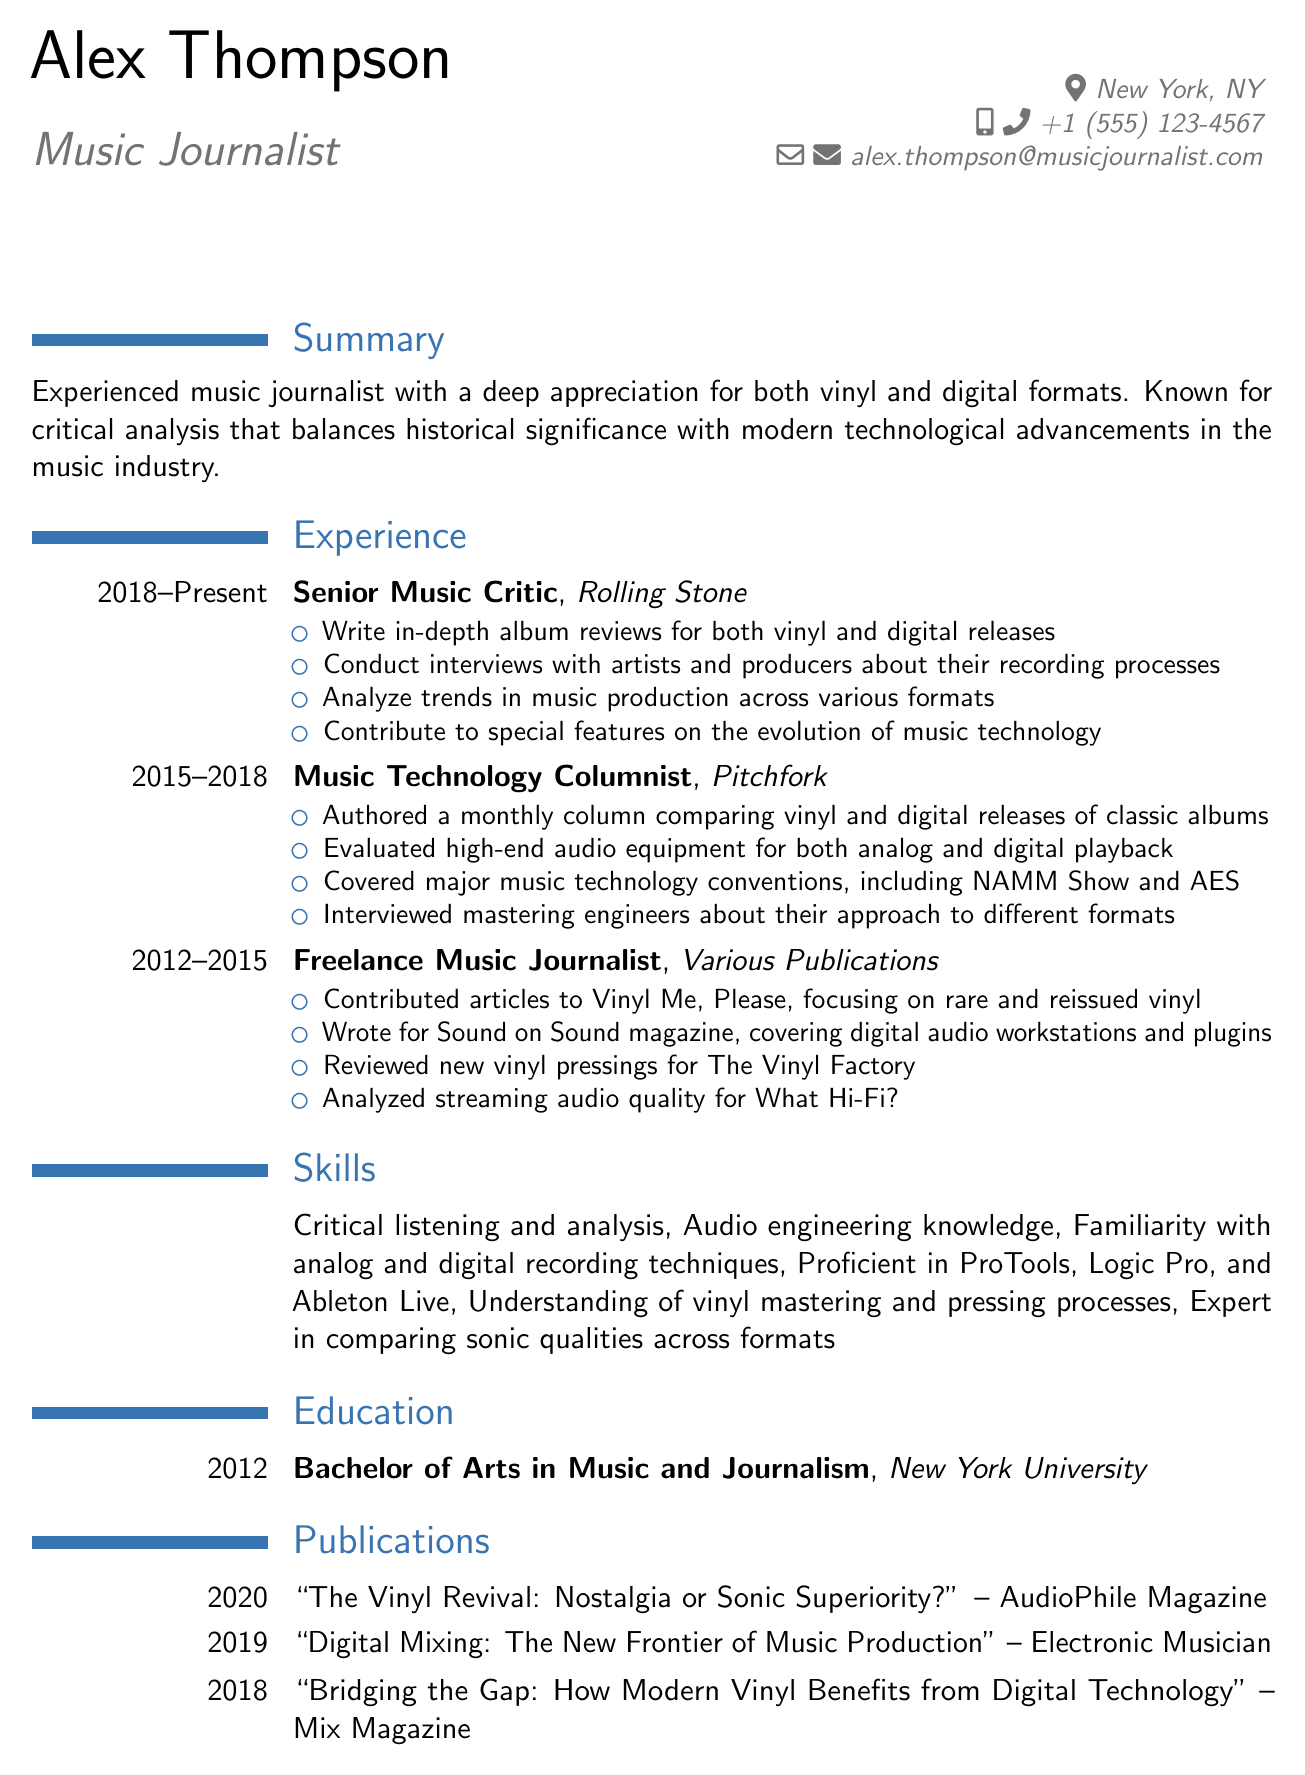What is the name of the journalist? The document provides the personal information section where the name is mentioned.
Answer: Alex Thompson What is the email address of Alex Thompson? The email is part of the personal information provided in the document.
Answer: alex.thompson@musicjournalist.com Which publication did Alex write for as a Senior Music Critic? This information is found under the work experience section, detailing past job titles and companies.
Answer: Rolling Stone How long did Alex work as a Music Technology Columnist? The duration is specified in the work experience section clearly showing the time frame.
Answer: 2015 - 2018 What is one of the skills Alex possesses? Skills are listed in a specific section within the document, providing various abilities of the journalist.
Answer: Critical listening and analysis What is the title of Alex's publication in 2020? This is found in the publications section, where each article title and date is clearly stated.
Answer: The Vinyl Revival: Nostalgia or Sonic Superiority? Name one professional affiliation of Alex. The professional affiliations section lists memberships and roles in organizations relevant to the profession.
Answer: Music Critics Association of North America What degree did Alex earn? The education section states the degree obtained by the journalist, showcasing their educational background.
Answer: Bachelor of Arts in Music and Journalism What type of articles did Alex contribute to Vinyl Me, Please? This information is included in the freelance journalist work experience section, detailing the type of writing done.
Answer: Rare and reissued vinyl How many years of experience does Alex have in music journalism? By adding up the years of experience from each job listed in the work experience section, the total can be deduced.
Answer: 11 years 